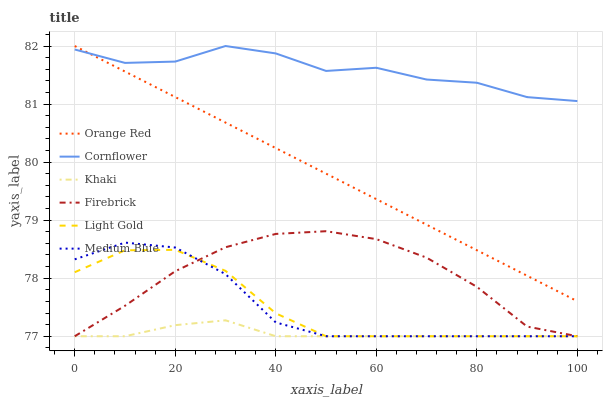Does Khaki have the minimum area under the curve?
Answer yes or no. Yes. Does Cornflower have the maximum area under the curve?
Answer yes or no. Yes. Does Firebrick have the minimum area under the curve?
Answer yes or no. No. Does Firebrick have the maximum area under the curve?
Answer yes or no. No. Is Orange Red the smoothest?
Answer yes or no. Yes. Is Cornflower the roughest?
Answer yes or no. Yes. Is Khaki the smoothest?
Answer yes or no. No. Is Khaki the roughest?
Answer yes or no. No. Does Khaki have the lowest value?
Answer yes or no. Yes. Does Orange Red have the lowest value?
Answer yes or no. No. Does Orange Red have the highest value?
Answer yes or no. Yes. Does Firebrick have the highest value?
Answer yes or no. No. Is Medium Blue less than Orange Red?
Answer yes or no. Yes. Is Orange Red greater than Light Gold?
Answer yes or no. Yes. Does Firebrick intersect Medium Blue?
Answer yes or no. Yes. Is Firebrick less than Medium Blue?
Answer yes or no. No. Is Firebrick greater than Medium Blue?
Answer yes or no. No. Does Medium Blue intersect Orange Red?
Answer yes or no. No. 